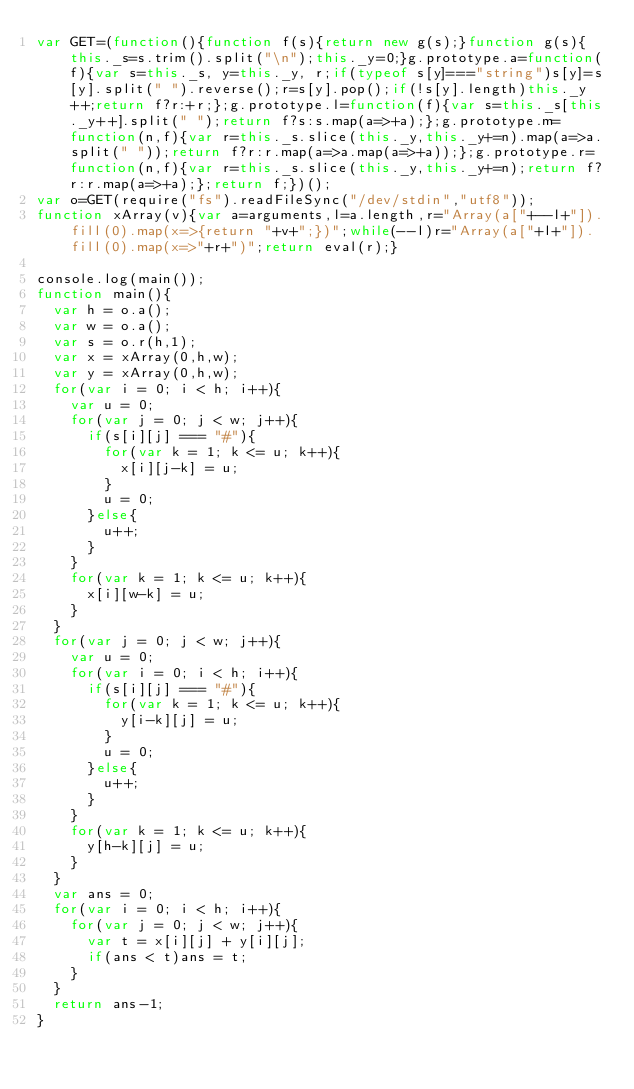<code> <loc_0><loc_0><loc_500><loc_500><_JavaScript_>var GET=(function(){function f(s){return new g(s);}function g(s){this._s=s.trim().split("\n");this._y=0;}g.prototype.a=function(f){var s=this._s, y=this._y, r;if(typeof s[y]==="string")s[y]=s[y].split(" ").reverse();r=s[y].pop();if(!s[y].length)this._y++;return f?r:+r;};g.prototype.l=function(f){var s=this._s[this._y++].split(" ");return f?s:s.map(a=>+a);};g.prototype.m=function(n,f){var r=this._s.slice(this._y,this._y+=n).map(a=>a.split(" "));return f?r:r.map(a=>a.map(a=>+a));};g.prototype.r=function(n,f){var r=this._s.slice(this._y,this._y+=n);return f?r:r.map(a=>+a);};return f;})();
var o=GET(require("fs").readFileSync("/dev/stdin","utf8"));
function xArray(v){var a=arguments,l=a.length,r="Array(a["+--l+"]).fill(0).map(x=>{return "+v+";})";while(--l)r="Array(a["+l+"]).fill(0).map(x=>"+r+")";return eval(r);}

console.log(main());
function main(){
  var h = o.a();
  var w = o.a();
  var s = o.r(h,1);
  var x = xArray(0,h,w);
  var y = xArray(0,h,w);
  for(var i = 0; i < h; i++){
    var u = 0;
    for(var j = 0; j < w; j++){
      if(s[i][j] === "#"){
        for(var k = 1; k <= u; k++){
          x[i][j-k] = u;
        }
        u = 0;
      }else{
        u++;
      }
    }
    for(var k = 1; k <= u; k++){
      x[i][w-k] = u;
    }
  }
  for(var j = 0; j < w; j++){
    var u = 0;
    for(var i = 0; i < h; i++){
      if(s[i][j] === "#"){
        for(var k = 1; k <= u; k++){
          y[i-k][j] = u;
        }
        u = 0;
      }else{
        u++;
      }
    }
    for(var k = 1; k <= u; k++){
      y[h-k][j] = u;
    }
  }
  var ans = 0;
  for(var i = 0; i < h; i++){
    for(var j = 0; j < w; j++){
      var t = x[i][j] + y[i][j];
      if(ans < t)ans = t;
    }
  }
  return ans-1;
}</code> 